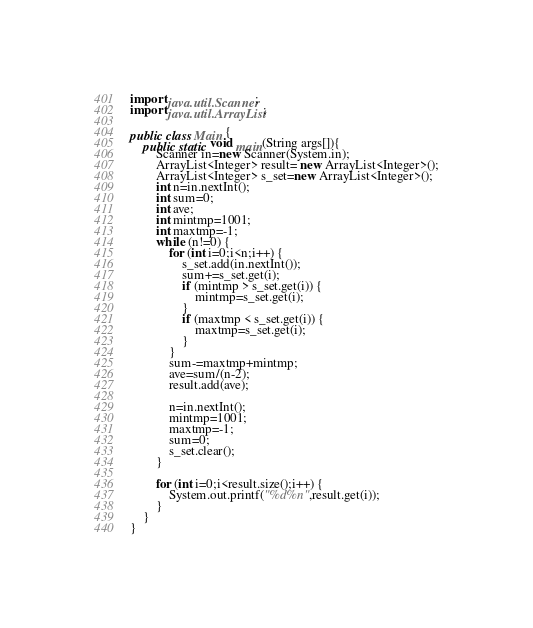Convert code to text. <code><loc_0><loc_0><loc_500><loc_500><_Java_>import java.util.Scanner;
import java.util.ArrayList;

public class Main {
	public static void main(String args[]){
		Scanner in=new Scanner(System.in);
		ArrayList<Integer> result= new ArrayList<Integer>();
		ArrayList<Integer> s_set=new ArrayList<Integer>();
		int n=in.nextInt();
		int sum=0;
		int ave;
		int mintmp=1001;
		int maxtmp=-1;
		while (n!=0) {
			for (int i=0;i<n;i++) {
				s_set.add(in.nextInt());
				sum+=s_set.get(i);
				if (mintmp > s_set.get(i)) {
					mintmp=s_set.get(i);
				}
				if (maxtmp < s_set.get(i)) {
					maxtmp=s_set.get(i);
				}
			}
			sum-=maxtmp+mintmp;
			ave=sum/(n-2);
			result.add(ave);

			n=in.nextInt();
			mintmp=1001;
			maxtmp=-1;
			sum=0;
			s_set.clear();
		}

		for (int i=0;i<result.size();i++) {
			System.out.printf("%d%n",result.get(i));
		}
	}
}</code> 